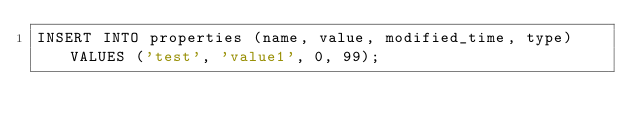<code> <loc_0><loc_0><loc_500><loc_500><_SQL_>INSERT INTO properties (name, value, modified_time, type) VALUES ('test', 'value1', 0, 99);
</code> 